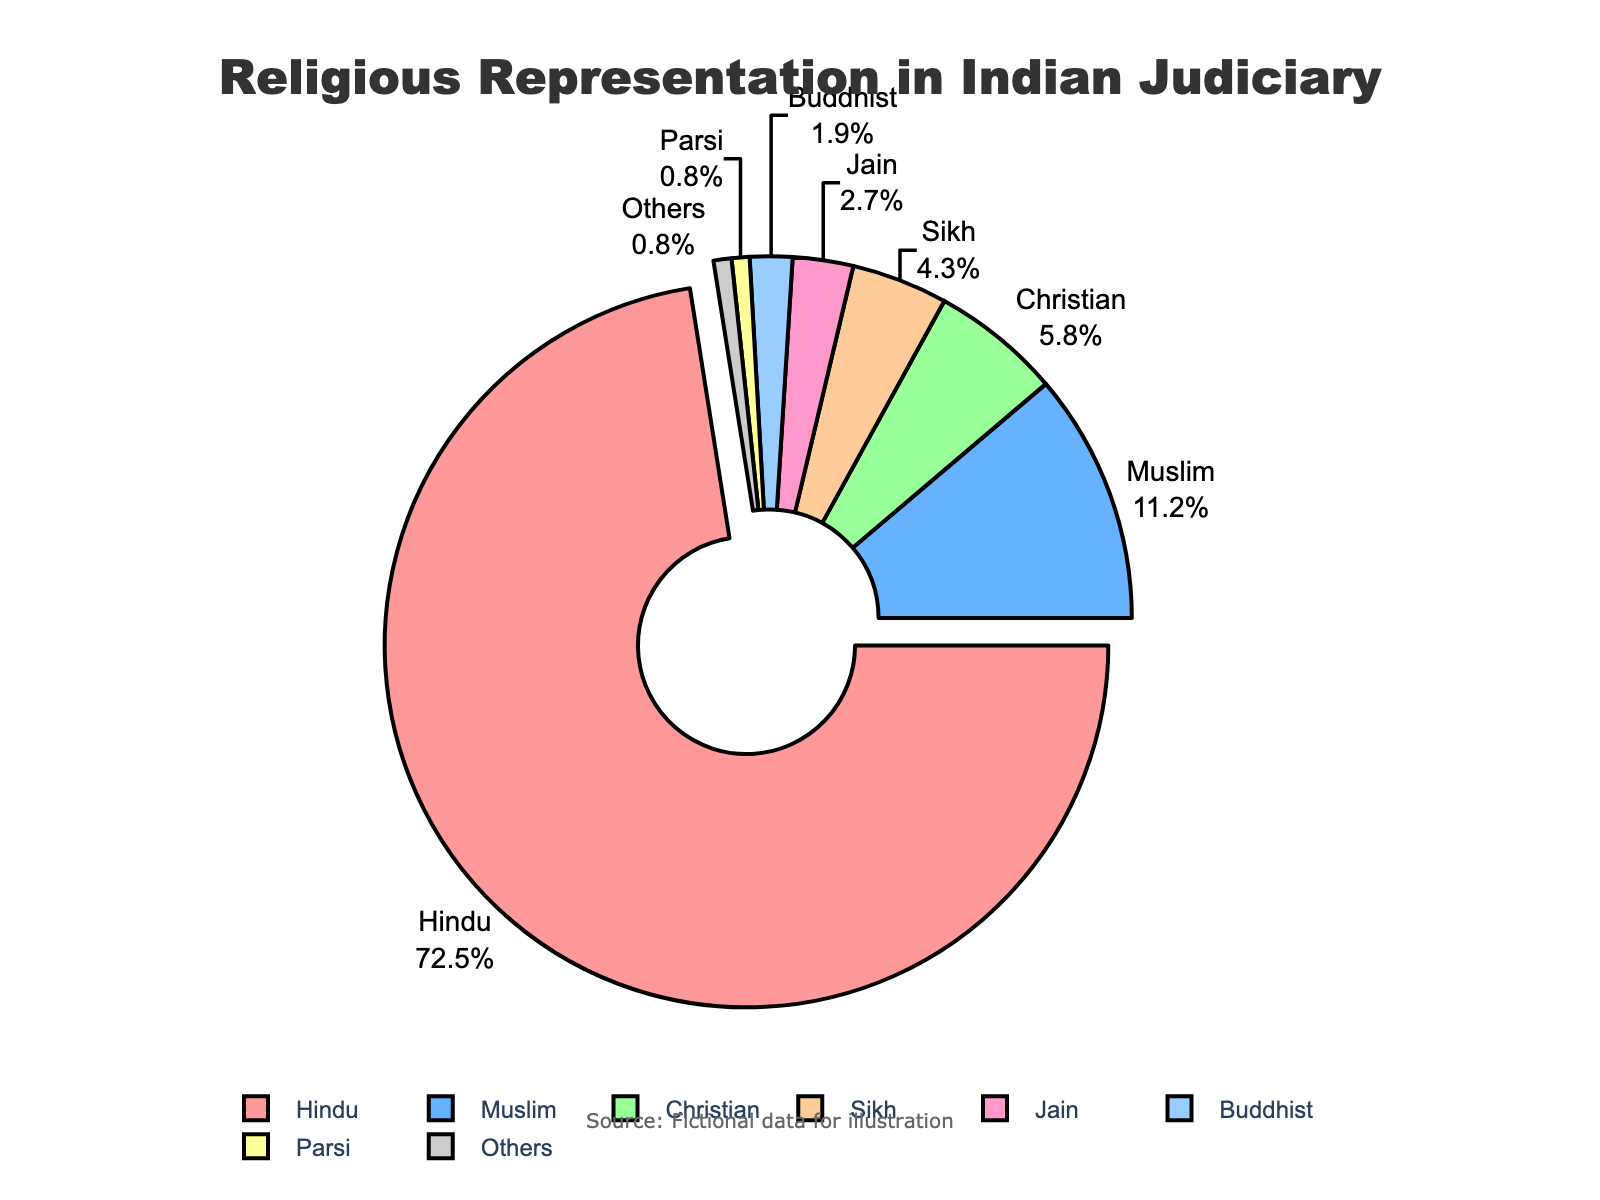What's the largest religious group represented in the Indian judiciary? The pie chart indicates that the Hindu community has the highest percentage among religious groups. It is visually distinguished by a larger segment and a pull-out effect highlighting its prominence.
Answer: Hindu What percentage of the Indian judiciary members belong to Muslim and Christian communities combined? From the pie chart, the Muslim community is 11.2% and the Christian community is 5.8%. Adding these percentages: 11.2% + 5.8% = 17%.
Answer: 17% Which is larger: the percentage of Sikh members or Jain members in the judiciary, and by how much? The percentage of Sikh members is 4.3%, and the percentage of Jain members is 2.7%. The difference is calculated as 4.3% - 2.7% = 1.6%.
Answer: Sikh by 1.6% How many communities each have less than 5% representation in the judiciary? The communities with less than 5% representation are Muslim (11.2%), Christian (5.8%), Sikh (4.3%), Jain (2.7%), Buddhist (1.9%), Parsi (0.8%), and Others (0.8%). Therefore, six communities have less than 5% representation.
Answer: 6 What is the difference in representation between the Hindu and the Buddhist communities? The Hindu community has 72.5% representation, and the Buddhist community has 1.9%. The difference is 72.5% - 1.9% = 70.6%.
Answer: 70.6% Which segment in the pie chart is denoted by a light green color, and what is its corresponding percentage? By observing the pie chart, the light green color segment corresponds to the Christian community with a percentage of 5.8%.
Answer: Christian; 5.8% If you sum up the percentages of the Parsi and Others communities, what would that total be? The Parsi community is 0.8%, and the Others community is also 0.8%. Summing these up gives: 0.8% + 0.8% = 1.6%.
Answer: 1.6% What is the average representation percentage of the Sikh, Jain, and Buddhist communities? The percentages are Sikh (4.3%), Jain (2.7%), and Buddhist (1.9%). The average is calculated as (4.3% + 2.7% + 1.9%) / 3 = 8.9% / 3 ≈ 2.97%.
Answer: 2.97% What communities represent exactly 0.8% of the judiciary members each? According to the pie chart, the Parsi and Others communities both each represent exactly 0.8% of judiciary members.
Answer: Parsi and Others 